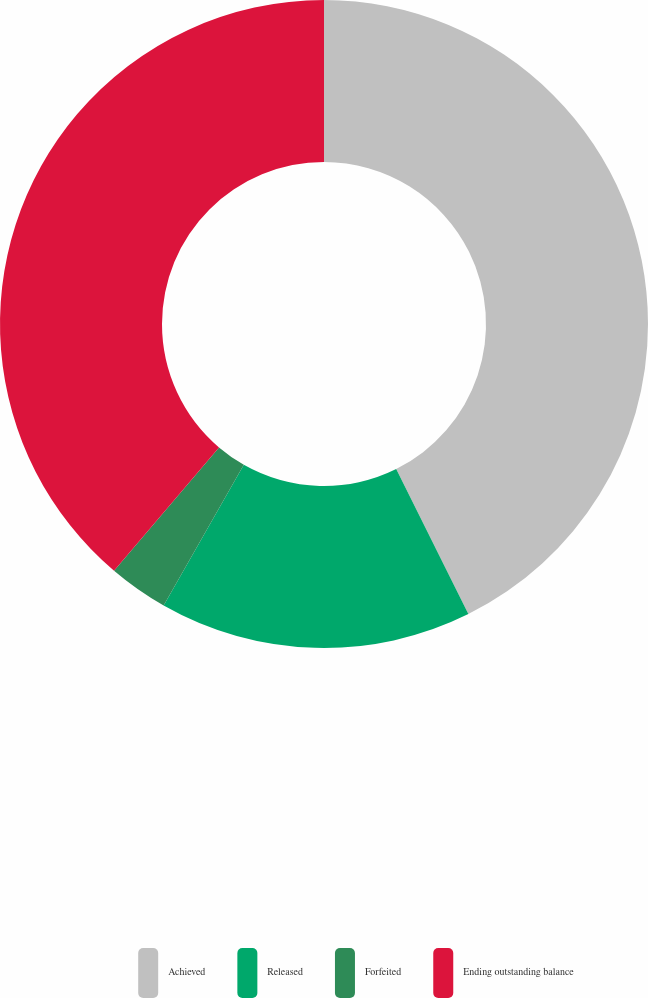<chart> <loc_0><loc_0><loc_500><loc_500><pie_chart><fcel>Achieved<fcel>Released<fcel>Forfeited<fcel>Ending outstanding balance<nl><fcel>42.65%<fcel>15.59%<fcel>2.98%<fcel>38.78%<nl></chart> 